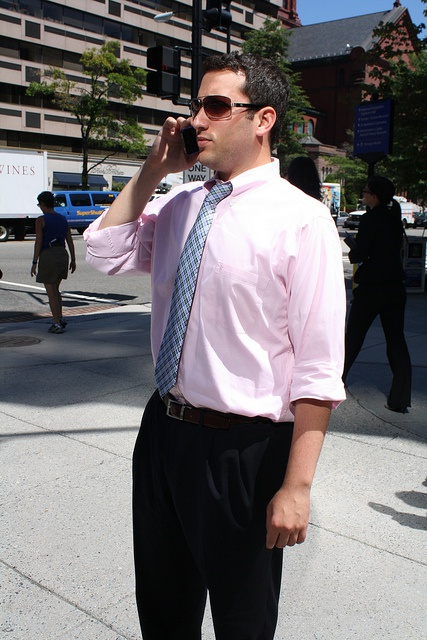Describe the objects in this image and their specific colors. I can see people in black, lavender, pink, and gray tones, people in black, darkgray, and gray tones, tie in black, gray, lavender, and darkgray tones, people in black, darkgray, lightgray, and gray tones, and truck in black, lightgray, darkgray, and gray tones in this image. 